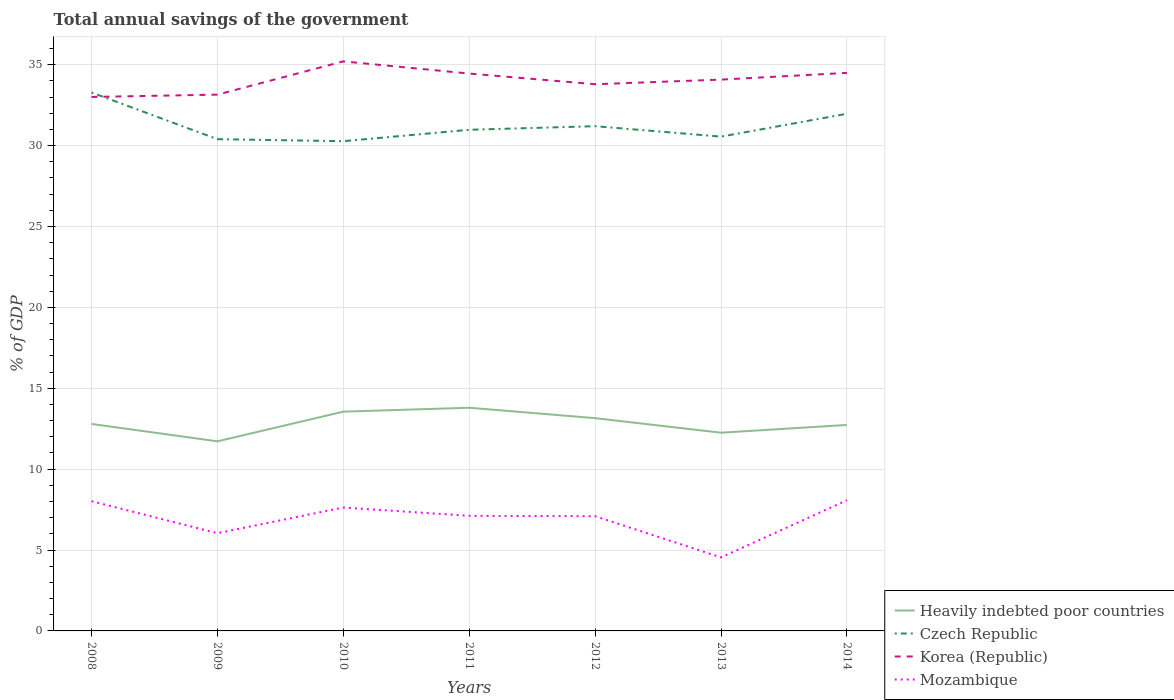How many different coloured lines are there?
Offer a very short reply. 4. Does the line corresponding to Korea (Republic) intersect with the line corresponding to Czech Republic?
Keep it short and to the point. Yes. Across all years, what is the maximum total annual savings of the government in Heavily indebted poor countries?
Ensure brevity in your answer.  11.72. What is the total total annual savings of the government in Heavily indebted poor countries in the graph?
Make the answer very short. 1.54. What is the difference between the highest and the second highest total annual savings of the government in Czech Republic?
Make the answer very short. 3.01. What is the difference between the highest and the lowest total annual savings of the government in Korea (Republic)?
Provide a succinct answer. 4. Is the total annual savings of the government in Czech Republic strictly greater than the total annual savings of the government in Mozambique over the years?
Offer a terse response. No. How are the legend labels stacked?
Provide a short and direct response. Vertical. What is the title of the graph?
Offer a very short reply. Total annual savings of the government. Does "Algeria" appear as one of the legend labels in the graph?
Your response must be concise. No. What is the label or title of the Y-axis?
Offer a terse response. % of GDP. What is the % of GDP in Heavily indebted poor countries in 2008?
Provide a succinct answer. 12.8. What is the % of GDP of Czech Republic in 2008?
Offer a very short reply. 33.28. What is the % of GDP of Korea (Republic) in 2008?
Ensure brevity in your answer.  33.01. What is the % of GDP in Mozambique in 2008?
Ensure brevity in your answer.  8.02. What is the % of GDP of Heavily indebted poor countries in 2009?
Ensure brevity in your answer.  11.72. What is the % of GDP of Czech Republic in 2009?
Your answer should be compact. 30.4. What is the % of GDP of Korea (Republic) in 2009?
Ensure brevity in your answer.  33.15. What is the % of GDP in Mozambique in 2009?
Give a very brief answer. 6.04. What is the % of GDP in Heavily indebted poor countries in 2010?
Give a very brief answer. 13.55. What is the % of GDP in Czech Republic in 2010?
Keep it short and to the point. 30.27. What is the % of GDP of Korea (Republic) in 2010?
Your response must be concise. 35.21. What is the % of GDP in Mozambique in 2010?
Give a very brief answer. 7.63. What is the % of GDP in Heavily indebted poor countries in 2011?
Offer a terse response. 13.8. What is the % of GDP in Czech Republic in 2011?
Your answer should be compact. 30.98. What is the % of GDP in Korea (Republic) in 2011?
Keep it short and to the point. 34.45. What is the % of GDP of Mozambique in 2011?
Your answer should be compact. 7.12. What is the % of GDP in Heavily indebted poor countries in 2012?
Offer a very short reply. 13.15. What is the % of GDP of Czech Republic in 2012?
Offer a very short reply. 31.2. What is the % of GDP in Korea (Republic) in 2012?
Offer a terse response. 33.8. What is the % of GDP in Mozambique in 2012?
Your answer should be very brief. 7.09. What is the % of GDP in Heavily indebted poor countries in 2013?
Offer a very short reply. 12.25. What is the % of GDP in Czech Republic in 2013?
Your response must be concise. 30.56. What is the % of GDP of Korea (Republic) in 2013?
Provide a short and direct response. 34.08. What is the % of GDP of Mozambique in 2013?
Make the answer very short. 4.54. What is the % of GDP in Heavily indebted poor countries in 2014?
Keep it short and to the point. 12.73. What is the % of GDP in Czech Republic in 2014?
Provide a short and direct response. 31.97. What is the % of GDP in Korea (Republic) in 2014?
Your response must be concise. 34.5. What is the % of GDP of Mozambique in 2014?
Keep it short and to the point. 8.08. Across all years, what is the maximum % of GDP of Heavily indebted poor countries?
Keep it short and to the point. 13.8. Across all years, what is the maximum % of GDP of Czech Republic?
Ensure brevity in your answer.  33.28. Across all years, what is the maximum % of GDP in Korea (Republic)?
Provide a succinct answer. 35.21. Across all years, what is the maximum % of GDP in Mozambique?
Provide a short and direct response. 8.08. Across all years, what is the minimum % of GDP of Heavily indebted poor countries?
Your answer should be compact. 11.72. Across all years, what is the minimum % of GDP of Czech Republic?
Your response must be concise. 30.27. Across all years, what is the minimum % of GDP of Korea (Republic)?
Offer a very short reply. 33.01. Across all years, what is the minimum % of GDP of Mozambique?
Give a very brief answer. 4.54. What is the total % of GDP of Heavily indebted poor countries in the graph?
Your answer should be very brief. 90.01. What is the total % of GDP in Czech Republic in the graph?
Offer a very short reply. 218.66. What is the total % of GDP in Korea (Republic) in the graph?
Your answer should be compact. 238.2. What is the total % of GDP in Mozambique in the graph?
Give a very brief answer. 48.52. What is the difference between the % of GDP in Heavily indebted poor countries in 2008 and that in 2009?
Give a very brief answer. 1.08. What is the difference between the % of GDP in Czech Republic in 2008 and that in 2009?
Provide a short and direct response. 2.88. What is the difference between the % of GDP in Korea (Republic) in 2008 and that in 2009?
Offer a very short reply. -0.14. What is the difference between the % of GDP of Mozambique in 2008 and that in 2009?
Provide a succinct answer. 1.98. What is the difference between the % of GDP of Heavily indebted poor countries in 2008 and that in 2010?
Provide a succinct answer. -0.76. What is the difference between the % of GDP of Czech Republic in 2008 and that in 2010?
Offer a very short reply. 3.01. What is the difference between the % of GDP in Mozambique in 2008 and that in 2010?
Offer a very short reply. 0.39. What is the difference between the % of GDP of Heavily indebted poor countries in 2008 and that in 2011?
Your response must be concise. -1. What is the difference between the % of GDP of Czech Republic in 2008 and that in 2011?
Keep it short and to the point. 2.3. What is the difference between the % of GDP of Korea (Republic) in 2008 and that in 2011?
Keep it short and to the point. -1.45. What is the difference between the % of GDP of Mozambique in 2008 and that in 2011?
Make the answer very short. 0.91. What is the difference between the % of GDP of Heavily indebted poor countries in 2008 and that in 2012?
Ensure brevity in your answer.  -0.36. What is the difference between the % of GDP in Czech Republic in 2008 and that in 2012?
Your response must be concise. 2.08. What is the difference between the % of GDP of Korea (Republic) in 2008 and that in 2012?
Your answer should be very brief. -0.79. What is the difference between the % of GDP in Mozambique in 2008 and that in 2012?
Give a very brief answer. 0.93. What is the difference between the % of GDP in Heavily indebted poor countries in 2008 and that in 2013?
Ensure brevity in your answer.  0.54. What is the difference between the % of GDP in Czech Republic in 2008 and that in 2013?
Make the answer very short. 2.73. What is the difference between the % of GDP of Korea (Republic) in 2008 and that in 2013?
Provide a succinct answer. -1.07. What is the difference between the % of GDP in Mozambique in 2008 and that in 2013?
Provide a succinct answer. 3.48. What is the difference between the % of GDP in Heavily indebted poor countries in 2008 and that in 2014?
Your answer should be compact. 0.06. What is the difference between the % of GDP of Czech Republic in 2008 and that in 2014?
Make the answer very short. 1.31. What is the difference between the % of GDP of Korea (Republic) in 2008 and that in 2014?
Your response must be concise. -1.49. What is the difference between the % of GDP in Mozambique in 2008 and that in 2014?
Provide a short and direct response. -0.06. What is the difference between the % of GDP of Heavily indebted poor countries in 2009 and that in 2010?
Offer a terse response. -1.83. What is the difference between the % of GDP of Czech Republic in 2009 and that in 2010?
Keep it short and to the point. 0.13. What is the difference between the % of GDP of Korea (Republic) in 2009 and that in 2010?
Keep it short and to the point. -2.06. What is the difference between the % of GDP in Mozambique in 2009 and that in 2010?
Your answer should be very brief. -1.59. What is the difference between the % of GDP of Heavily indebted poor countries in 2009 and that in 2011?
Keep it short and to the point. -2.08. What is the difference between the % of GDP of Czech Republic in 2009 and that in 2011?
Keep it short and to the point. -0.58. What is the difference between the % of GDP in Korea (Republic) in 2009 and that in 2011?
Provide a succinct answer. -1.3. What is the difference between the % of GDP in Mozambique in 2009 and that in 2011?
Give a very brief answer. -1.07. What is the difference between the % of GDP of Heavily indebted poor countries in 2009 and that in 2012?
Provide a short and direct response. -1.43. What is the difference between the % of GDP in Czech Republic in 2009 and that in 2012?
Offer a very short reply. -0.8. What is the difference between the % of GDP of Korea (Republic) in 2009 and that in 2012?
Offer a terse response. -0.64. What is the difference between the % of GDP of Mozambique in 2009 and that in 2012?
Provide a succinct answer. -1.05. What is the difference between the % of GDP of Heavily indebted poor countries in 2009 and that in 2013?
Make the answer very short. -0.53. What is the difference between the % of GDP in Czech Republic in 2009 and that in 2013?
Offer a very short reply. -0.16. What is the difference between the % of GDP in Korea (Republic) in 2009 and that in 2013?
Your response must be concise. -0.93. What is the difference between the % of GDP in Mozambique in 2009 and that in 2013?
Keep it short and to the point. 1.5. What is the difference between the % of GDP of Heavily indebted poor countries in 2009 and that in 2014?
Offer a very short reply. -1.01. What is the difference between the % of GDP of Czech Republic in 2009 and that in 2014?
Provide a short and direct response. -1.57. What is the difference between the % of GDP in Korea (Republic) in 2009 and that in 2014?
Your answer should be compact. -1.34. What is the difference between the % of GDP of Mozambique in 2009 and that in 2014?
Make the answer very short. -2.04. What is the difference between the % of GDP in Heavily indebted poor countries in 2010 and that in 2011?
Keep it short and to the point. -0.24. What is the difference between the % of GDP of Czech Republic in 2010 and that in 2011?
Give a very brief answer. -0.71. What is the difference between the % of GDP in Korea (Republic) in 2010 and that in 2011?
Your response must be concise. 0.75. What is the difference between the % of GDP in Mozambique in 2010 and that in 2011?
Give a very brief answer. 0.51. What is the difference between the % of GDP of Heavily indebted poor countries in 2010 and that in 2012?
Give a very brief answer. 0.4. What is the difference between the % of GDP of Czech Republic in 2010 and that in 2012?
Give a very brief answer. -0.93. What is the difference between the % of GDP of Korea (Republic) in 2010 and that in 2012?
Your answer should be compact. 1.41. What is the difference between the % of GDP of Mozambique in 2010 and that in 2012?
Your response must be concise. 0.54. What is the difference between the % of GDP of Heavily indebted poor countries in 2010 and that in 2013?
Offer a terse response. 1.3. What is the difference between the % of GDP of Czech Republic in 2010 and that in 2013?
Provide a short and direct response. -0.28. What is the difference between the % of GDP in Korea (Republic) in 2010 and that in 2013?
Provide a succinct answer. 1.13. What is the difference between the % of GDP in Mozambique in 2010 and that in 2013?
Your response must be concise. 3.08. What is the difference between the % of GDP of Heavily indebted poor countries in 2010 and that in 2014?
Give a very brief answer. 0.82. What is the difference between the % of GDP in Czech Republic in 2010 and that in 2014?
Offer a very short reply. -1.7. What is the difference between the % of GDP of Korea (Republic) in 2010 and that in 2014?
Your answer should be very brief. 0.71. What is the difference between the % of GDP in Mozambique in 2010 and that in 2014?
Give a very brief answer. -0.45. What is the difference between the % of GDP of Heavily indebted poor countries in 2011 and that in 2012?
Give a very brief answer. 0.65. What is the difference between the % of GDP of Czech Republic in 2011 and that in 2012?
Provide a succinct answer. -0.22. What is the difference between the % of GDP of Korea (Republic) in 2011 and that in 2012?
Provide a succinct answer. 0.66. What is the difference between the % of GDP of Mozambique in 2011 and that in 2012?
Provide a succinct answer. 0.02. What is the difference between the % of GDP of Heavily indebted poor countries in 2011 and that in 2013?
Provide a succinct answer. 1.54. What is the difference between the % of GDP in Czech Republic in 2011 and that in 2013?
Ensure brevity in your answer.  0.42. What is the difference between the % of GDP in Korea (Republic) in 2011 and that in 2013?
Give a very brief answer. 0.37. What is the difference between the % of GDP of Mozambique in 2011 and that in 2013?
Provide a succinct answer. 2.57. What is the difference between the % of GDP in Heavily indebted poor countries in 2011 and that in 2014?
Your answer should be very brief. 1.06. What is the difference between the % of GDP of Czech Republic in 2011 and that in 2014?
Offer a very short reply. -0.99. What is the difference between the % of GDP in Korea (Republic) in 2011 and that in 2014?
Ensure brevity in your answer.  -0.04. What is the difference between the % of GDP of Mozambique in 2011 and that in 2014?
Offer a very short reply. -0.96. What is the difference between the % of GDP of Heavily indebted poor countries in 2012 and that in 2013?
Offer a terse response. 0.9. What is the difference between the % of GDP in Czech Republic in 2012 and that in 2013?
Your answer should be very brief. 0.64. What is the difference between the % of GDP in Korea (Republic) in 2012 and that in 2013?
Ensure brevity in your answer.  -0.29. What is the difference between the % of GDP of Mozambique in 2012 and that in 2013?
Your response must be concise. 2.55. What is the difference between the % of GDP of Heavily indebted poor countries in 2012 and that in 2014?
Offer a very short reply. 0.42. What is the difference between the % of GDP in Czech Republic in 2012 and that in 2014?
Offer a terse response. -0.77. What is the difference between the % of GDP in Korea (Republic) in 2012 and that in 2014?
Provide a succinct answer. -0.7. What is the difference between the % of GDP of Mozambique in 2012 and that in 2014?
Make the answer very short. -0.99. What is the difference between the % of GDP of Heavily indebted poor countries in 2013 and that in 2014?
Provide a short and direct response. -0.48. What is the difference between the % of GDP in Czech Republic in 2013 and that in 2014?
Give a very brief answer. -1.41. What is the difference between the % of GDP of Korea (Republic) in 2013 and that in 2014?
Provide a short and direct response. -0.42. What is the difference between the % of GDP in Mozambique in 2013 and that in 2014?
Your response must be concise. -3.54. What is the difference between the % of GDP in Heavily indebted poor countries in 2008 and the % of GDP in Czech Republic in 2009?
Give a very brief answer. -17.6. What is the difference between the % of GDP of Heavily indebted poor countries in 2008 and the % of GDP of Korea (Republic) in 2009?
Your response must be concise. -20.36. What is the difference between the % of GDP in Heavily indebted poor countries in 2008 and the % of GDP in Mozambique in 2009?
Your answer should be compact. 6.75. What is the difference between the % of GDP in Czech Republic in 2008 and the % of GDP in Korea (Republic) in 2009?
Your answer should be compact. 0.13. What is the difference between the % of GDP of Czech Republic in 2008 and the % of GDP of Mozambique in 2009?
Keep it short and to the point. 27.24. What is the difference between the % of GDP of Korea (Republic) in 2008 and the % of GDP of Mozambique in 2009?
Make the answer very short. 26.97. What is the difference between the % of GDP of Heavily indebted poor countries in 2008 and the % of GDP of Czech Republic in 2010?
Ensure brevity in your answer.  -17.48. What is the difference between the % of GDP in Heavily indebted poor countries in 2008 and the % of GDP in Korea (Republic) in 2010?
Provide a short and direct response. -22.41. What is the difference between the % of GDP in Heavily indebted poor countries in 2008 and the % of GDP in Mozambique in 2010?
Your response must be concise. 5.17. What is the difference between the % of GDP in Czech Republic in 2008 and the % of GDP in Korea (Republic) in 2010?
Ensure brevity in your answer.  -1.92. What is the difference between the % of GDP in Czech Republic in 2008 and the % of GDP in Mozambique in 2010?
Offer a very short reply. 25.66. What is the difference between the % of GDP of Korea (Republic) in 2008 and the % of GDP of Mozambique in 2010?
Ensure brevity in your answer.  25.38. What is the difference between the % of GDP in Heavily indebted poor countries in 2008 and the % of GDP in Czech Republic in 2011?
Your response must be concise. -18.18. What is the difference between the % of GDP in Heavily indebted poor countries in 2008 and the % of GDP in Korea (Republic) in 2011?
Offer a very short reply. -21.66. What is the difference between the % of GDP in Heavily indebted poor countries in 2008 and the % of GDP in Mozambique in 2011?
Offer a terse response. 5.68. What is the difference between the % of GDP of Czech Republic in 2008 and the % of GDP of Korea (Republic) in 2011?
Your answer should be compact. -1.17. What is the difference between the % of GDP in Czech Republic in 2008 and the % of GDP in Mozambique in 2011?
Provide a succinct answer. 26.17. What is the difference between the % of GDP in Korea (Republic) in 2008 and the % of GDP in Mozambique in 2011?
Ensure brevity in your answer.  25.89. What is the difference between the % of GDP of Heavily indebted poor countries in 2008 and the % of GDP of Czech Republic in 2012?
Make the answer very short. -18.41. What is the difference between the % of GDP in Heavily indebted poor countries in 2008 and the % of GDP in Korea (Republic) in 2012?
Make the answer very short. -21. What is the difference between the % of GDP in Heavily indebted poor countries in 2008 and the % of GDP in Mozambique in 2012?
Your response must be concise. 5.71. What is the difference between the % of GDP of Czech Republic in 2008 and the % of GDP of Korea (Republic) in 2012?
Offer a very short reply. -0.51. What is the difference between the % of GDP of Czech Republic in 2008 and the % of GDP of Mozambique in 2012?
Your answer should be very brief. 26.19. What is the difference between the % of GDP of Korea (Republic) in 2008 and the % of GDP of Mozambique in 2012?
Give a very brief answer. 25.92. What is the difference between the % of GDP in Heavily indebted poor countries in 2008 and the % of GDP in Czech Republic in 2013?
Provide a succinct answer. -17.76. What is the difference between the % of GDP in Heavily indebted poor countries in 2008 and the % of GDP in Korea (Republic) in 2013?
Make the answer very short. -21.29. What is the difference between the % of GDP in Heavily indebted poor countries in 2008 and the % of GDP in Mozambique in 2013?
Offer a terse response. 8.25. What is the difference between the % of GDP in Czech Republic in 2008 and the % of GDP in Korea (Republic) in 2013?
Offer a very short reply. -0.8. What is the difference between the % of GDP of Czech Republic in 2008 and the % of GDP of Mozambique in 2013?
Your response must be concise. 28.74. What is the difference between the % of GDP in Korea (Republic) in 2008 and the % of GDP in Mozambique in 2013?
Keep it short and to the point. 28.46. What is the difference between the % of GDP in Heavily indebted poor countries in 2008 and the % of GDP in Czech Republic in 2014?
Make the answer very short. -19.17. What is the difference between the % of GDP in Heavily indebted poor countries in 2008 and the % of GDP in Korea (Republic) in 2014?
Your response must be concise. -21.7. What is the difference between the % of GDP of Heavily indebted poor countries in 2008 and the % of GDP of Mozambique in 2014?
Offer a terse response. 4.72. What is the difference between the % of GDP in Czech Republic in 2008 and the % of GDP in Korea (Republic) in 2014?
Make the answer very short. -1.21. What is the difference between the % of GDP in Czech Republic in 2008 and the % of GDP in Mozambique in 2014?
Give a very brief answer. 25.2. What is the difference between the % of GDP in Korea (Republic) in 2008 and the % of GDP in Mozambique in 2014?
Offer a very short reply. 24.93. What is the difference between the % of GDP in Heavily indebted poor countries in 2009 and the % of GDP in Czech Republic in 2010?
Provide a short and direct response. -18.55. What is the difference between the % of GDP in Heavily indebted poor countries in 2009 and the % of GDP in Korea (Republic) in 2010?
Offer a terse response. -23.49. What is the difference between the % of GDP in Heavily indebted poor countries in 2009 and the % of GDP in Mozambique in 2010?
Ensure brevity in your answer.  4.09. What is the difference between the % of GDP of Czech Republic in 2009 and the % of GDP of Korea (Republic) in 2010?
Ensure brevity in your answer.  -4.81. What is the difference between the % of GDP in Czech Republic in 2009 and the % of GDP in Mozambique in 2010?
Make the answer very short. 22.77. What is the difference between the % of GDP of Korea (Republic) in 2009 and the % of GDP of Mozambique in 2010?
Make the answer very short. 25.52. What is the difference between the % of GDP in Heavily indebted poor countries in 2009 and the % of GDP in Czech Republic in 2011?
Make the answer very short. -19.26. What is the difference between the % of GDP in Heavily indebted poor countries in 2009 and the % of GDP in Korea (Republic) in 2011?
Your answer should be very brief. -22.73. What is the difference between the % of GDP in Heavily indebted poor countries in 2009 and the % of GDP in Mozambique in 2011?
Provide a short and direct response. 4.6. What is the difference between the % of GDP in Czech Republic in 2009 and the % of GDP in Korea (Republic) in 2011?
Provide a short and direct response. -4.05. What is the difference between the % of GDP in Czech Republic in 2009 and the % of GDP in Mozambique in 2011?
Ensure brevity in your answer.  23.28. What is the difference between the % of GDP of Korea (Republic) in 2009 and the % of GDP of Mozambique in 2011?
Give a very brief answer. 26.04. What is the difference between the % of GDP in Heavily indebted poor countries in 2009 and the % of GDP in Czech Republic in 2012?
Provide a short and direct response. -19.48. What is the difference between the % of GDP of Heavily indebted poor countries in 2009 and the % of GDP of Korea (Republic) in 2012?
Ensure brevity in your answer.  -22.08. What is the difference between the % of GDP in Heavily indebted poor countries in 2009 and the % of GDP in Mozambique in 2012?
Offer a very short reply. 4.63. What is the difference between the % of GDP of Czech Republic in 2009 and the % of GDP of Korea (Republic) in 2012?
Provide a succinct answer. -3.4. What is the difference between the % of GDP in Czech Republic in 2009 and the % of GDP in Mozambique in 2012?
Your answer should be compact. 23.31. What is the difference between the % of GDP of Korea (Republic) in 2009 and the % of GDP of Mozambique in 2012?
Keep it short and to the point. 26.06. What is the difference between the % of GDP of Heavily indebted poor countries in 2009 and the % of GDP of Czech Republic in 2013?
Provide a short and direct response. -18.84. What is the difference between the % of GDP of Heavily indebted poor countries in 2009 and the % of GDP of Korea (Republic) in 2013?
Provide a succinct answer. -22.36. What is the difference between the % of GDP in Heavily indebted poor countries in 2009 and the % of GDP in Mozambique in 2013?
Provide a succinct answer. 7.18. What is the difference between the % of GDP in Czech Republic in 2009 and the % of GDP in Korea (Republic) in 2013?
Your response must be concise. -3.68. What is the difference between the % of GDP of Czech Republic in 2009 and the % of GDP of Mozambique in 2013?
Keep it short and to the point. 25.85. What is the difference between the % of GDP in Korea (Republic) in 2009 and the % of GDP in Mozambique in 2013?
Offer a very short reply. 28.61. What is the difference between the % of GDP of Heavily indebted poor countries in 2009 and the % of GDP of Czech Republic in 2014?
Your answer should be compact. -20.25. What is the difference between the % of GDP in Heavily indebted poor countries in 2009 and the % of GDP in Korea (Republic) in 2014?
Provide a succinct answer. -22.78. What is the difference between the % of GDP of Heavily indebted poor countries in 2009 and the % of GDP of Mozambique in 2014?
Keep it short and to the point. 3.64. What is the difference between the % of GDP of Czech Republic in 2009 and the % of GDP of Korea (Republic) in 2014?
Your response must be concise. -4.1. What is the difference between the % of GDP of Czech Republic in 2009 and the % of GDP of Mozambique in 2014?
Provide a succinct answer. 22.32. What is the difference between the % of GDP in Korea (Republic) in 2009 and the % of GDP in Mozambique in 2014?
Keep it short and to the point. 25.07. What is the difference between the % of GDP in Heavily indebted poor countries in 2010 and the % of GDP in Czech Republic in 2011?
Your response must be concise. -17.43. What is the difference between the % of GDP of Heavily indebted poor countries in 2010 and the % of GDP of Korea (Republic) in 2011?
Provide a succinct answer. -20.9. What is the difference between the % of GDP in Heavily indebted poor countries in 2010 and the % of GDP in Mozambique in 2011?
Offer a very short reply. 6.44. What is the difference between the % of GDP of Czech Republic in 2010 and the % of GDP of Korea (Republic) in 2011?
Give a very brief answer. -4.18. What is the difference between the % of GDP of Czech Republic in 2010 and the % of GDP of Mozambique in 2011?
Your answer should be very brief. 23.16. What is the difference between the % of GDP of Korea (Republic) in 2010 and the % of GDP of Mozambique in 2011?
Keep it short and to the point. 28.09. What is the difference between the % of GDP of Heavily indebted poor countries in 2010 and the % of GDP of Czech Republic in 2012?
Keep it short and to the point. -17.65. What is the difference between the % of GDP in Heavily indebted poor countries in 2010 and the % of GDP in Korea (Republic) in 2012?
Offer a very short reply. -20.24. What is the difference between the % of GDP in Heavily indebted poor countries in 2010 and the % of GDP in Mozambique in 2012?
Ensure brevity in your answer.  6.46. What is the difference between the % of GDP in Czech Republic in 2010 and the % of GDP in Korea (Republic) in 2012?
Provide a succinct answer. -3.52. What is the difference between the % of GDP in Czech Republic in 2010 and the % of GDP in Mozambique in 2012?
Provide a short and direct response. 23.18. What is the difference between the % of GDP in Korea (Republic) in 2010 and the % of GDP in Mozambique in 2012?
Keep it short and to the point. 28.12. What is the difference between the % of GDP in Heavily indebted poor countries in 2010 and the % of GDP in Czech Republic in 2013?
Offer a very short reply. -17. What is the difference between the % of GDP of Heavily indebted poor countries in 2010 and the % of GDP of Korea (Republic) in 2013?
Provide a short and direct response. -20.53. What is the difference between the % of GDP of Heavily indebted poor countries in 2010 and the % of GDP of Mozambique in 2013?
Keep it short and to the point. 9.01. What is the difference between the % of GDP of Czech Republic in 2010 and the % of GDP of Korea (Republic) in 2013?
Make the answer very short. -3.81. What is the difference between the % of GDP of Czech Republic in 2010 and the % of GDP of Mozambique in 2013?
Ensure brevity in your answer.  25.73. What is the difference between the % of GDP in Korea (Republic) in 2010 and the % of GDP in Mozambique in 2013?
Give a very brief answer. 30.66. What is the difference between the % of GDP in Heavily indebted poor countries in 2010 and the % of GDP in Czech Republic in 2014?
Offer a very short reply. -18.41. What is the difference between the % of GDP in Heavily indebted poor countries in 2010 and the % of GDP in Korea (Republic) in 2014?
Offer a very short reply. -20.94. What is the difference between the % of GDP of Heavily indebted poor countries in 2010 and the % of GDP of Mozambique in 2014?
Offer a very short reply. 5.47. What is the difference between the % of GDP of Czech Republic in 2010 and the % of GDP of Korea (Republic) in 2014?
Provide a short and direct response. -4.22. What is the difference between the % of GDP in Czech Republic in 2010 and the % of GDP in Mozambique in 2014?
Provide a short and direct response. 22.19. What is the difference between the % of GDP in Korea (Republic) in 2010 and the % of GDP in Mozambique in 2014?
Provide a succinct answer. 27.13. What is the difference between the % of GDP in Heavily indebted poor countries in 2011 and the % of GDP in Czech Republic in 2012?
Offer a very short reply. -17.4. What is the difference between the % of GDP in Heavily indebted poor countries in 2011 and the % of GDP in Korea (Republic) in 2012?
Ensure brevity in your answer.  -20. What is the difference between the % of GDP of Heavily indebted poor countries in 2011 and the % of GDP of Mozambique in 2012?
Provide a succinct answer. 6.71. What is the difference between the % of GDP in Czech Republic in 2011 and the % of GDP in Korea (Republic) in 2012?
Provide a short and direct response. -2.82. What is the difference between the % of GDP of Czech Republic in 2011 and the % of GDP of Mozambique in 2012?
Make the answer very short. 23.89. What is the difference between the % of GDP in Korea (Republic) in 2011 and the % of GDP in Mozambique in 2012?
Give a very brief answer. 27.36. What is the difference between the % of GDP in Heavily indebted poor countries in 2011 and the % of GDP in Czech Republic in 2013?
Provide a succinct answer. -16.76. What is the difference between the % of GDP in Heavily indebted poor countries in 2011 and the % of GDP in Korea (Republic) in 2013?
Your response must be concise. -20.28. What is the difference between the % of GDP of Heavily indebted poor countries in 2011 and the % of GDP of Mozambique in 2013?
Your response must be concise. 9.25. What is the difference between the % of GDP of Czech Republic in 2011 and the % of GDP of Korea (Republic) in 2013?
Your answer should be very brief. -3.1. What is the difference between the % of GDP in Czech Republic in 2011 and the % of GDP in Mozambique in 2013?
Offer a terse response. 26.44. What is the difference between the % of GDP in Korea (Republic) in 2011 and the % of GDP in Mozambique in 2013?
Your answer should be very brief. 29.91. What is the difference between the % of GDP in Heavily indebted poor countries in 2011 and the % of GDP in Czech Republic in 2014?
Make the answer very short. -18.17. What is the difference between the % of GDP in Heavily indebted poor countries in 2011 and the % of GDP in Korea (Republic) in 2014?
Make the answer very short. -20.7. What is the difference between the % of GDP of Heavily indebted poor countries in 2011 and the % of GDP of Mozambique in 2014?
Offer a terse response. 5.72. What is the difference between the % of GDP of Czech Republic in 2011 and the % of GDP of Korea (Republic) in 2014?
Your answer should be very brief. -3.52. What is the difference between the % of GDP of Czech Republic in 2011 and the % of GDP of Mozambique in 2014?
Make the answer very short. 22.9. What is the difference between the % of GDP in Korea (Republic) in 2011 and the % of GDP in Mozambique in 2014?
Give a very brief answer. 26.37. What is the difference between the % of GDP in Heavily indebted poor countries in 2012 and the % of GDP in Czech Republic in 2013?
Your answer should be very brief. -17.4. What is the difference between the % of GDP in Heavily indebted poor countries in 2012 and the % of GDP in Korea (Republic) in 2013?
Your answer should be very brief. -20.93. What is the difference between the % of GDP in Heavily indebted poor countries in 2012 and the % of GDP in Mozambique in 2013?
Your answer should be very brief. 8.61. What is the difference between the % of GDP in Czech Republic in 2012 and the % of GDP in Korea (Republic) in 2013?
Ensure brevity in your answer.  -2.88. What is the difference between the % of GDP of Czech Republic in 2012 and the % of GDP of Mozambique in 2013?
Give a very brief answer. 26.66. What is the difference between the % of GDP of Korea (Republic) in 2012 and the % of GDP of Mozambique in 2013?
Give a very brief answer. 29.25. What is the difference between the % of GDP of Heavily indebted poor countries in 2012 and the % of GDP of Czech Republic in 2014?
Make the answer very short. -18.82. What is the difference between the % of GDP of Heavily indebted poor countries in 2012 and the % of GDP of Korea (Republic) in 2014?
Offer a terse response. -21.34. What is the difference between the % of GDP in Heavily indebted poor countries in 2012 and the % of GDP in Mozambique in 2014?
Ensure brevity in your answer.  5.07. What is the difference between the % of GDP of Czech Republic in 2012 and the % of GDP of Korea (Republic) in 2014?
Give a very brief answer. -3.3. What is the difference between the % of GDP in Czech Republic in 2012 and the % of GDP in Mozambique in 2014?
Offer a very short reply. 23.12. What is the difference between the % of GDP of Korea (Republic) in 2012 and the % of GDP of Mozambique in 2014?
Give a very brief answer. 25.72. What is the difference between the % of GDP of Heavily indebted poor countries in 2013 and the % of GDP of Czech Republic in 2014?
Make the answer very short. -19.72. What is the difference between the % of GDP in Heavily indebted poor countries in 2013 and the % of GDP in Korea (Republic) in 2014?
Give a very brief answer. -22.24. What is the difference between the % of GDP in Heavily indebted poor countries in 2013 and the % of GDP in Mozambique in 2014?
Provide a short and direct response. 4.17. What is the difference between the % of GDP of Czech Republic in 2013 and the % of GDP of Korea (Republic) in 2014?
Give a very brief answer. -3.94. What is the difference between the % of GDP of Czech Republic in 2013 and the % of GDP of Mozambique in 2014?
Your answer should be very brief. 22.48. What is the difference between the % of GDP of Korea (Republic) in 2013 and the % of GDP of Mozambique in 2014?
Give a very brief answer. 26. What is the average % of GDP in Heavily indebted poor countries per year?
Give a very brief answer. 12.86. What is the average % of GDP of Czech Republic per year?
Your response must be concise. 31.24. What is the average % of GDP in Korea (Republic) per year?
Provide a succinct answer. 34.03. What is the average % of GDP in Mozambique per year?
Provide a succinct answer. 6.93. In the year 2008, what is the difference between the % of GDP in Heavily indebted poor countries and % of GDP in Czech Republic?
Offer a terse response. -20.49. In the year 2008, what is the difference between the % of GDP in Heavily indebted poor countries and % of GDP in Korea (Republic)?
Provide a succinct answer. -20.21. In the year 2008, what is the difference between the % of GDP of Heavily indebted poor countries and % of GDP of Mozambique?
Give a very brief answer. 4.77. In the year 2008, what is the difference between the % of GDP in Czech Republic and % of GDP in Korea (Republic)?
Provide a succinct answer. 0.28. In the year 2008, what is the difference between the % of GDP of Czech Republic and % of GDP of Mozambique?
Your answer should be compact. 25.26. In the year 2008, what is the difference between the % of GDP of Korea (Republic) and % of GDP of Mozambique?
Your response must be concise. 24.99. In the year 2009, what is the difference between the % of GDP of Heavily indebted poor countries and % of GDP of Czech Republic?
Your answer should be very brief. -18.68. In the year 2009, what is the difference between the % of GDP in Heavily indebted poor countries and % of GDP in Korea (Republic)?
Give a very brief answer. -21.43. In the year 2009, what is the difference between the % of GDP of Heavily indebted poor countries and % of GDP of Mozambique?
Ensure brevity in your answer.  5.68. In the year 2009, what is the difference between the % of GDP in Czech Republic and % of GDP in Korea (Republic)?
Provide a succinct answer. -2.75. In the year 2009, what is the difference between the % of GDP in Czech Republic and % of GDP in Mozambique?
Make the answer very short. 24.36. In the year 2009, what is the difference between the % of GDP in Korea (Republic) and % of GDP in Mozambique?
Offer a terse response. 27.11. In the year 2010, what is the difference between the % of GDP of Heavily indebted poor countries and % of GDP of Czech Republic?
Keep it short and to the point. -16.72. In the year 2010, what is the difference between the % of GDP of Heavily indebted poor countries and % of GDP of Korea (Republic)?
Offer a very short reply. -21.65. In the year 2010, what is the difference between the % of GDP in Heavily indebted poor countries and % of GDP in Mozambique?
Make the answer very short. 5.93. In the year 2010, what is the difference between the % of GDP in Czech Republic and % of GDP in Korea (Republic)?
Give a very brief answer. -4.93. In the year 2010, what is the difference between the % of GDP of Czech Republic and % of GDP of Mozambique?
Your answer should be very brief. 22.64. In the year 2010, what is the difference between the % of GDP in Korea (Republic) and % of GDP in Mozambique?
Keep it short and to the point. 27.58. In the year 2011, what is the difference between the % of GDP in Heavily indebted poor countries and % of GDP in Czech Republic?
Your answer should be compact. -17.18. In the year 2011, what is the difference between the % of GDP of Heavily indebted poor countries and % of GDP of Korea (Republic)?
Make the answer very short. -20.66. In the year 2011, what is the difference between the % of GDP in Heavily indebted poor countries and % of GDP in Mozambique?
Provide a succinct answer. 6.68. In the year 2011, what is the difference between the % of GDP of Czech Republic and % of GDP of Korea (Republic)?
Keep it short and to the point. -3.47. In the year 2011, what is the difference between the % of GDP of Czech Republic and % of GDP of Mozambique?
Your answer should be compact. 23.86. In the year 2011, what is the difference between the % of GDP of Korea (Republic) and % of GDP of Mozambique?
Your answer should be compact. 27.34. In the year 2012, what is the difference between the % of GDP of Heavily indebted poor countries and % of GDP of Czech Republic?
Keep it short and to the point. -18.05. In the year 2012, what is the difference between the % of GDP in Heavily indebted poor countries and % of GDP in Korea (Republic)?
Give a very brief answer. -20.64. In the year 2012, what is the difference between the % of GDP in Heavily indebted poor countries and % of GDP in Mozambique?
Make the answer very short. 6.06. In the year 2012, what is the difference between the % of GDP of Czech Republic and % of GDP of Korea (Republic)?
Keep it short and to the point. -2.59. In the year 2012, what is the difference between the % of GDP of Czech Republic and % of GDP of Mozambique?
Your response must be concise. 24.11. In the year 2012, what is the difference between the % of GDP in Korea (Republic) and % of GDP in Mozambique?
Provide a succinct answer. 26.7. In the year 2013, what is the difference between the % of GDP of Heavily indebted poor countries and % of GDP of Czech Republic?
Provide a succinct answer. -18.3. In the year 2013, what is the difference between the % of GDP in Heavily indebted poor countries and % of GDP in Korea (Republic)?
Your response must be concise. -21.83. In the year 2013, what is the difference between the % of GDP in Heavily indebted poor countries and % of GDP in Mozambique?
Keep it short and to the point. 7.71. In the year 2013, what is the difference between the % of GDP in Czech Republic and % of GDP in Korea (Republic)?
Provide a short and direct response. -3.53. In the year 2013, what is the difference between the % of GDP of Czech Republic and % of GDP of Mozambique?
Your answer should be compact. 26.01. In the year 2013, what is the difference between the % of GDP in Korea (Republic) and % of GDP in Mozambique?
Make the answer very short. 29.54. In the year 2014, what is the difference between the % of GDP in Heavily indebted poor countries and % of GDP in Czech Republic?
Give a very brief answer. -19.24. In the year 2014, what is the difference between the % of GDP in Heavily indebted poor countries and % of GDP in Korea (Republic)?
Your answer should be very brief. -21.76. In the year 2014, what is the difference between the % of GDP of Heavily indebted poor countries and % of GDP of Mozambique?
Offer a very short reply. 4.65. In the year 2014, what is the difference between the % of GDP of Czech Republic and % of GDP of Korea (Republic)?
Offer a terse response. -2.53. In the year 2014, what is the difference between the % of GDP in Czech Republic and % of GDP in Mozambique?
Keep it short and to the point. 23.89. In the year 2014, what is the difference between the % of GDP of Korea (Republic) and % of GDP of Mozambique?
Ensure brevity in your answer.  26.42. What is the ratio of the % of GDP in Heavily indebted poor countries in 2008 to that in 2009?
Your answer should be compact. 1.09. What is the ratio of the % of GDP in Czech Republic in 2008 to that in 2009?
Offer a terse response. 1.09. What is the ratio of the % of GDP of Mozambique in 2008 to that in 2009?
Offer a very short reply. 1.33. What is the ratio of the % of GDP of Heavily indebted poor countries in 2008 to that in 2010?
Your answer should be compact. 0.94. What is the ratio of the % of GDP of Czech Republic in 2008 to that in 2010?
Your answer should be very brief. 1.1. What is the ratio of the % of GDP in Mozambique in 2008 to that in 2010?
Offer a very short reply. 1.05. What is the ratio of the % of GDP in Heavily indebted poor countries in 2008 to that in 2011?
Make the answer very short. 0.93. What is the ratio of the % of GDP of Czech Republic in 2008 to that in 2011?
Keep it short and to the point. 1.07. What is the ratio of the % of GDP of Korea (Republic) in 2008 to that in 2011?
Your response must be concise. 0.96. What is the ratio of the % of GDP in Mozambique in 2008 to that in 2011?
Keep it short and to the point. 1.13. What is the ratio of the % of GDP of Heavily indebted poor countries in 2008 to that in 2012?
Offer a terse response. 0.97. What is the ratio of the % of GDP in Czech Republic in 2008 to that in 2012?
Give a very brief answer. 1.07. What is the ratio of the % of GDP in Korea (Republic) in 2008 to that in 2012?
Your response must be concise. 0.98. What is the ratio of the % of GDP of Mozambique in 2008 to that in 2012?
Make the answer very short. 1.13. What is the ratio of the % of GDP of Heavily indebted poor countries in 2008 to that in 2013?
Ensure brevity in your answer.  1.04. What is the ratio of the % of GDP of Czech Republic in 2008 to that in 2013?
Your response must be concise. 1.09. What is the ratio of the % of GDP in Korea (Republic) in 2008 to that in 2013?
Give a very brief answer. 0.97. What is the ratio of the % of GDP of Mozambique in 2008 to that in 2013?
Ensure brevity in your answer.  1.77. What is the ratio of the % of GDP of Heavily indebted poor countries in 2008 to that in 2014?
Provide a short and direct response. 1. What is the ratio of the % of GDP of Czech Republic in 2008 to that in 2014?
Your answer should be compact. 1.04. What is the ratio of the % of GDP of Korea (Republic) in 2008 to that in 2014?
Offer a terse response. 0.96. What is the ratio of the % of GDP of Mozambique in 2008 to that in 2014?
Offer a very short reply. 0.99. What is the ratio of the % of GDP in Heavily indebted poor countries in 2009 to that in 2010?
Keep it short and to the point. 0.86. What is the ratio of the % of GDP of Korea (Republic) in 2009 to that in 2010?
Offer a terse response. 0.94. What is the ratio of the % of GDP of Mozambique in 2009 to that in 2010?
Keep it short and to the point. 0.79. What is the ratio of the % of GDP of Heavily indebted poor countries in 2009 to that in 2011?
Your answer should be very brief. 0.85. What is the ratio of the % of GDP in Czech Republic in 2009 to that in 2011?
Your answer should be very brief. 0.98. What is the ratio of the % of GDP in Korea (Republic) in 2009 to that in 2011?
Your answer should be compact. 0.96. What is the ratio of the % of GDP in Mozambique in 2009 to that in 2011?
Provide a short and direct response. 0.85. What is the ratio of the % of GDP in Heavily indebted poor countries in 2009 to that in 2012?
Your response must be concise. 0.89. What is the ratio of the % of GDP of Czech Republic in 2009 to that in 2012?
Offer a very short reply. 0.97. What is the ratio of the % of GDP of Korea (Republic) in 2009 to that in 2012?
Offer a very short reply. 0.98. What is the ratio of the % of GDP in Mozambique in 2009 to that in 2012?
Provide a succinct answer. 0.85. What is the ratio of the % of GDP in Heavily indebted poor countries in 2009 to that in 2013?
Provide a short and direct response. 0.96. What is the ratio of the % of GDP of Czech Republic in 2009 to that in 2013?
Your response must be concise. 0.99. What is the ratio of the % of GDP of Korea (Republic) in 2009 to that in 2013?
Offer a very short reply. 0.97. What is the ratio of the % of GDP in Mozambique in 2009 to that in 2013?
Keep it short and to the point. 1.33. What is the ratio of the % of GDP in Heavily indebted poor countries in 2009 to that in 2014?
Provide a succinct answer. 0.92. What is the ratio of the % of GDP in Czech Republic in 2009 to that in 2014?
Make the answer very short. 0.95. What is the ratio of the % of GDP of Korea (Republic) in 2009 to that in 2014?
Provide a short and direct response. 0.96. What is the ratio of the % of GDP in Mozambique in 2009 to that in 2014?
Your response must be concise. 0.75. What is the ratio of the % of GDP in Heavily indebted poor countries in 2010 to that in 2011?
Provide a succinct answer. 0.98. What is the ratio of the % of GDP in Czech Republic in 2010 to that in 2011?
Provide a succinct answer. 0.98. What is the ratio of the % of GDP in Korea (Republic) in 2010 to that in 2011?
Keep it short and to the point. 1.02. What is the ratio of the % of GDP in Mozambique in 2010 to that in 2011?
Make the answer very short. 1.07. What is the ratio of the % of GDP of Heavily indebted poor countries in 2010 to that in 2012?
Your answer should be very brief. 1.03. What is the ratio of the % of GDP of Czech Republic in 2010 to that in 2012?
Provide a short and direct response. 0.97. What is the ratio of the % of GDP of Korea (Republic) in 2010 to that in 2012?
Ensure brevity in your answer.  1.04. What is the ratio of the % of GDP of Mozambique in 2010 to that in 2012?
Make the answer very short. 1.08. What is the ratio of the % of GDP in Heavily indebted poor countries in 2010 to that in 2013?
Keep it short and to the point. 1.11. What is the ratio of the % of GDP in Czech Republic in 2010 to that in 2013?
Provide a succinct answer. 0.99. What is the ratio of the % of GDP of Korea (Republic) in 2010 to that in 2013?
Your answer should be compact. 1.03. What is the ratio of the % of GDP in Mozambique in 2010 to that in 2013?
Your answer should be very brief. 1.68. What is the ratio of the % of GDP of Heavily indebted poor countries in 2010 to that in 2014?
Keep it short and to the point. 1.06. What is the ratio of the % of GDP of Czech Republic in 2010 to that in 2014?
Offer a terse response. 0.95. What is the ratio of the % of GDP of Korea (Republic) in 2010 to that in 2014?
Your answer should be compact. 1.02. What is the ratio of the % of GDP of Mozambique in 2010 to that in 2014?
Offer a terse response. 0.94. What is the ratio of the % of GDP in Heavily indebted poor countries in 2011 to that in 2012?
Make the answer very short. 1.05. What is the ratio of the % of GDP of Korea (Republic) in 2011 to that in 2012?
Provide a succinct answer. 1.02. What is the ratio of the % of GDP in Heavily indebted poor countries in 2011 to that in 2013?
Keep it short and to the point. 1.13. What is the ratio of the % of GDP of Czech Republic in 2011 to that in 2013?
Your answer should be compact. 1.01. What is the ratio of the % of GDP in Korea (Republic) in 2011 to that in 2013?
Your answer should be compact. 1.01. What is the ratio of the % of GDP in Mozambique in 2011 to that in 2013?
Your answer should be very brief. 1.57. What is the ratio of the % of GDP of Heavily indebted poor countries in 2011 to that in 2014?
Provide a short and direct response. 1.08. What is the ratio of the % of GDP in Mozambique in 2011 to that in 2014?
Offer a very short reply. 0.88. What is the ratio of the % of GDP in Heavily indebted poor countries in 2012 to that in 2013?
Make the answer very short. 1.07. What is the ratio of the % of GDP of Czech Republic in 2012 to that in 2013?
Keep it short and to the point. 1.02. What is the ratio of the % of GDP in Korea (Republic) in 2012 to that in 2013?
Provide a succinct answer. 0.99. What is the ratio of the % of GDP of Mozambique in 2012 to that in 2013?
Your answer should be very brief. 1.56. What is the ratio of the % of GDP of Heavily indebted poor countries in 2012 to that in 2014?
Provide a succinct answer. 1.03. What is the ratio of the % of GDP of Czech Republic in 2012 to that in 2014?
Make the answer very short. 0.98. What is the ratio of the % of GDP in Korea (Republic) in 2012 to that in 2014?
Offer a very short reply. 0.98. What is the ratio of the % of GDP in Mozambique in 2012 to that in 2014?
Make the answer very short. 0.88. What is the ratio of the % of GDP of Heavily indebted poor countries in 2013 to that in 2014?
Give a very brief answer. 0.96. What is the ratio of the % of GDP in Czech Republic in 2013 to that in 2014?
Offer a very short reply. 0.96. What is the ratio of the % of GDP of Mozambique in 2013 to that in 2014?
Ensure brevity in your answer.  0.56. What is the difference between the highest and the second highest % of GDP in Heavily indebted poor countries?
Provide a short and direct response. 0.24. What is the difference between the highest and the second highest % of GDP in Czech Republic?
Ensure brevity in your answer.  1.31. What is the difference between the highest and the second highest % of GDP of Korea (Republic)?
Your response must be concise. 0.71. What is the difference between the highest and the second highest % of GDP in Mozambique?
Keep it short and to the point. 0.06. What is the difference between the highest and the lowest % of GDP of Heavily indebted poor countries?
Make the answer very short. 2.08. What is the difference between the highest and the lowest % of GDP of Czech Republic?
Your answer should be compact. 3.01. What is the difference between the highest and the lowest % of GDP in Mozambique?
Offer a very short reply. 3.54. 